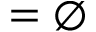Convert formula to latex. <formula><loc_0><loc_0><loc_500><loc_500>= \emptyset</formula> 